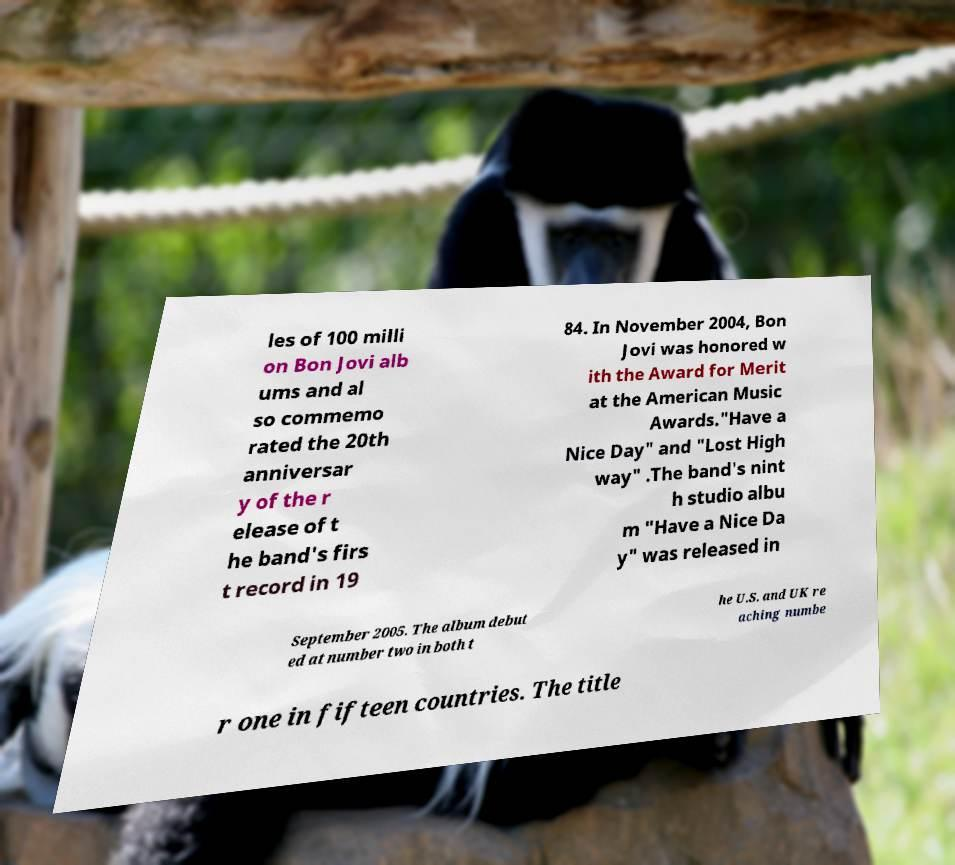Please identify and transcribe the text found in this image. les of 100 milli on Bon Jovi alb ums and al so commemo rated the 20th anniversar y of the r elease of t he band's firs t record in 19 84. In November 2004, Bon Jovi was honored w ith the Award for Merit at the American Music Awards."Have a Nice Day" and "Lost High way" .The band's nint h studio albu m "Have a Nice Da y" was released in September 2005. The album debut ed at number two in both t he U.S. and UK re aching numbe r one in fifteen countries. The title 